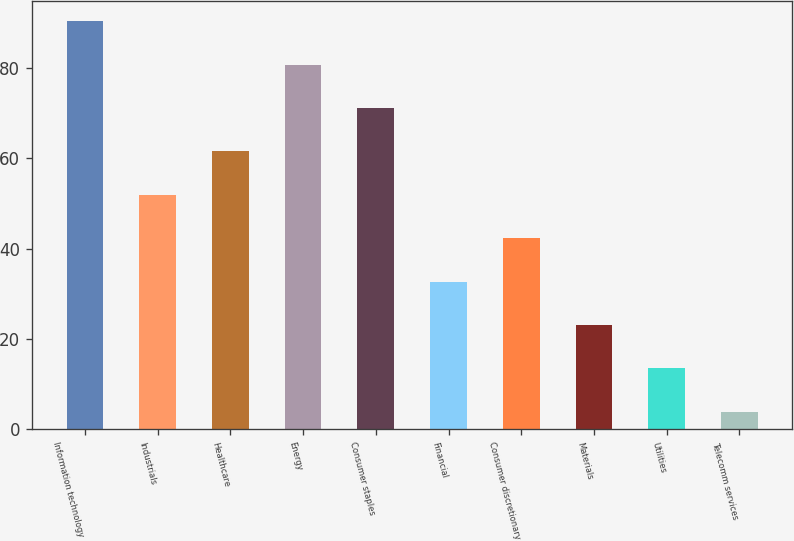Convert chart to OTSL. <chart><loc_0><loc_0><loc_500><loc_500><bar_chart><fcel>Information technology<fcel>Industrials<fcel>Healthcare<fcel>Energy<fcel>Consumer staples<fcel>Financial<fcel>Consumer discretionary<fcel>Materials<fcel>Utilities<fcel>Telecomm services<nl><fcel>90.39<fcel>51.95<fcel>61.56<fcel>80.78<fcel>71.17<fcel>32.73<fcel>42.34<fcel>23.12<fcel>13.51<fcel>3.9<nl></chart> 